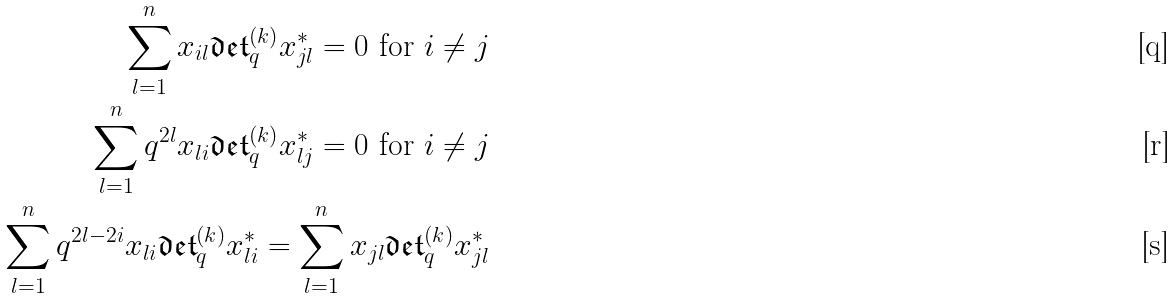Convert formula to latex. <formula><loc_0><loc_0><loc_500><loc_500>\sum _ { l = 1 } ^ { n } x _ { i l } \mathfrak { d e t } _ { q } ^ { ( k ) } x _ { j l } ^ { * } = 0 \text { for } i \neq j \\ \sum _ { l = 1 } ^ { n } q ^ { 2 l } x _ { l i } \mathfrak { d e t } _ { q } ^ { ( k ) } x _ { l j } ^ { * } = 0 \text { for } i \neq j \\ \sum _ { l = 1 } ^ { n } q ^ { 2 l - 2 i } x _ { l i } \mathfrak { d e t } _ { q } ^ { ( k ) } x _ { l i } ^ { * } = \sum _ { l = 1 } ^ { n } x _ { j l } \mathfrak { d e t } _ { q } ^ { ( k ) } x _ { j l } ^ { * }</formula> 